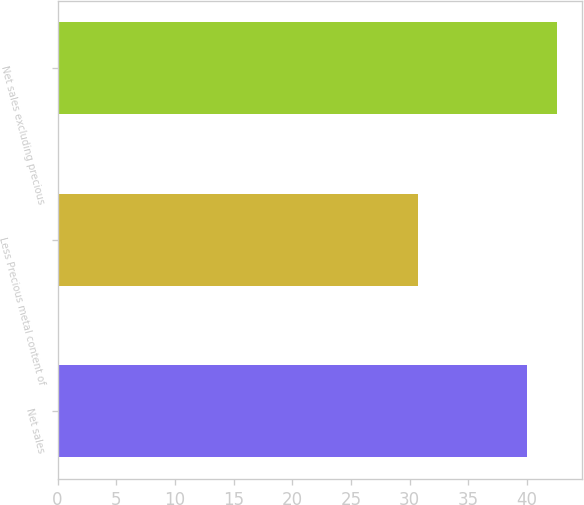Convert chart. <chart><loc_0><loc_0><loc_500><loc_500><bar_chart><fcel>Net sales<fcel>Less Precious metal content of<fcel>Net sales excluding precious<nl><fcel>40<fcel>30.7<fcel>42.6<nl></chart> 